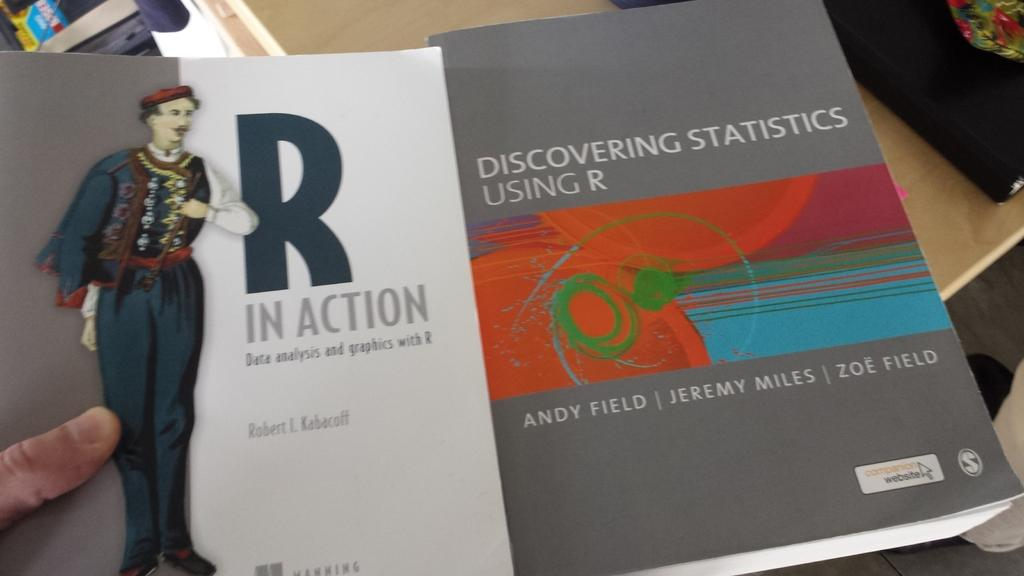<image>
Render a clear and concise summary of the photo. A book with a grey cover called Discovering Statistics Using R. 